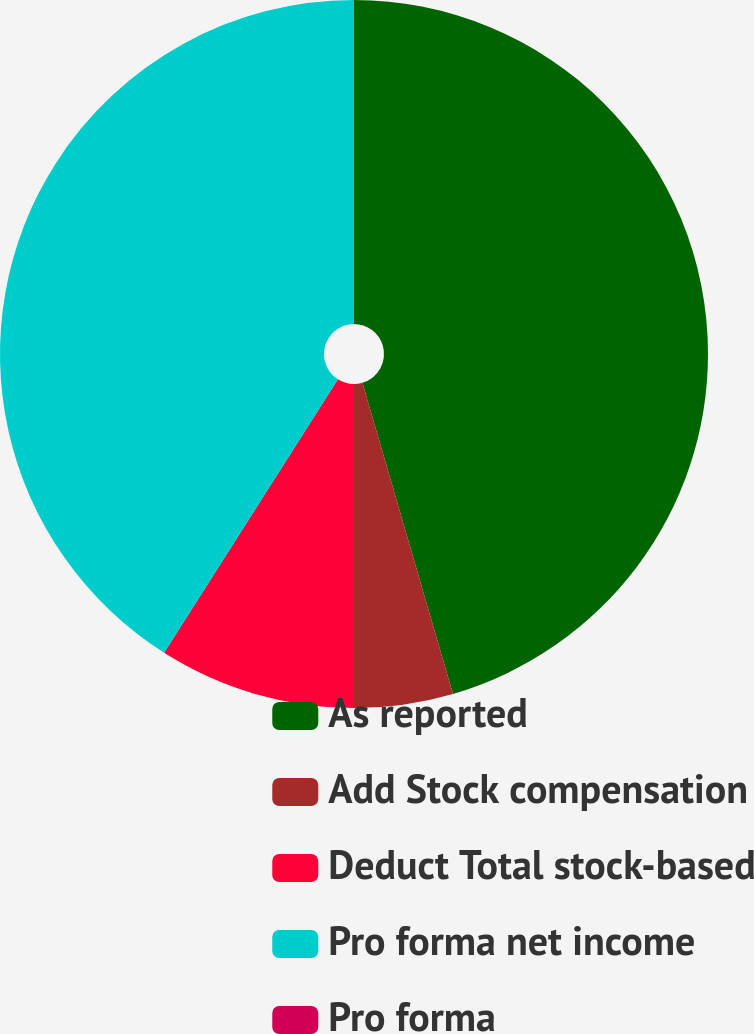Convert chart to OTSL. <chart><loc_0><loc_0><loc_500><loc_500><pie_chart><fcel>As reported<fcel>Add Stock compensation<fcel>Deduct Total stock-based<fcel>Pro forma net income<fcel>Pro forma<nl><fcel>45.49%<fcel>4.51%<fcel>9.01%<fcel>40.99%<fcel>0.0%<nl></chart> 